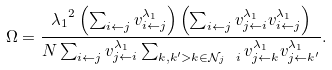<formula> <loc_0><loc_0><loc_500><loc_500>\Omega = \frac { { \lambda _ { 1 } } ^ { 2 } \left ( \sum _ { i \leftarrow j } v ^ { \lambda _ { 1 } } _ { i \leftarrow j } \right ) \left ( \sum _ { i \leftarrow j } v ^ { \lambda _ { 1 } } _ { j \leftarrow i } v ^ { \lambda _ { 1 } } _ { i \leftarrow j } \right ) } { N \sum _ { i \leftarrow j } v ^ { \lambda _ { 1 } } _ { j \leftarrow i } \sum _ { k , k ^ { \prime } > k \in \mathcal { N } _ { j } \ i } v ^ { \lambda _ { 1 } } _ { j \leftarrow k } v ^ { \lambda _ { 1 } } _ { j \leftarrow k ^ { \prime } } } .</formula> 